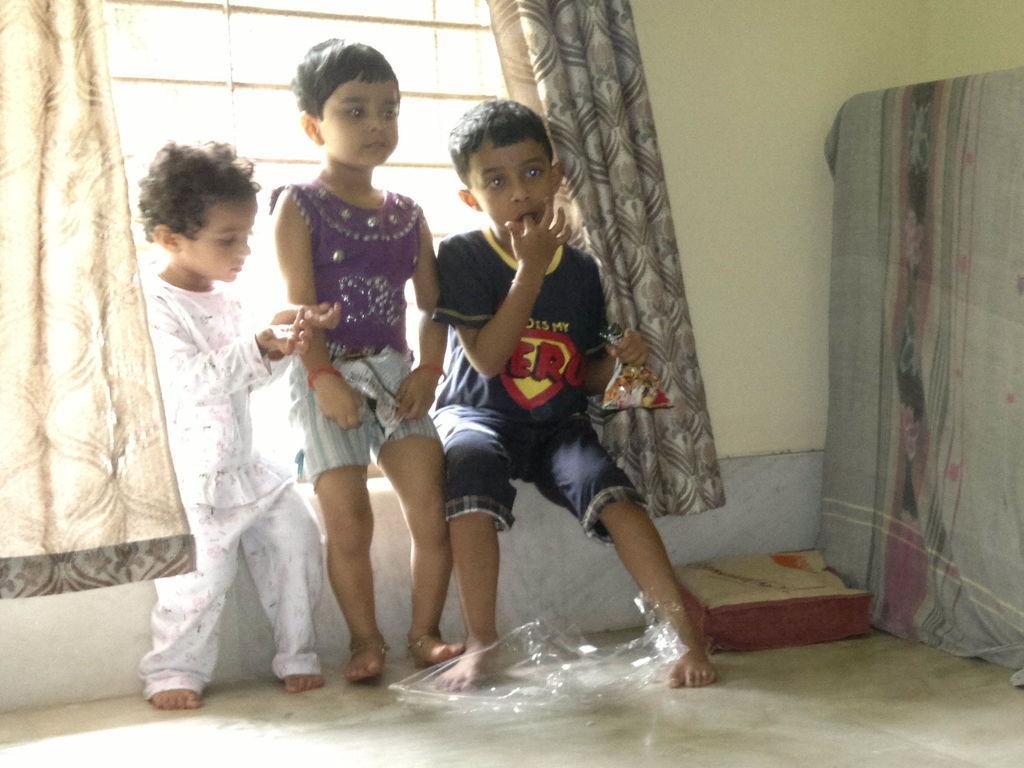Could you give a brief overview of what you see in this image? In this image I can see three kids on the floor, pillow, cloth, curtains, wall and a window. This image is taken may be in a hall. 